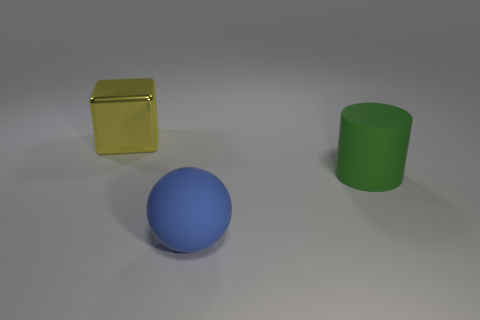There is a block that is the same size as the cylinder; what is it made of? The block appears to have a reflective surface and a golden hue, suggesting that it is made of a material that mimics the appearance of polished metal, potentially plastic with a metallic finish, commonly used in computer-generated imagery for visual effects. 